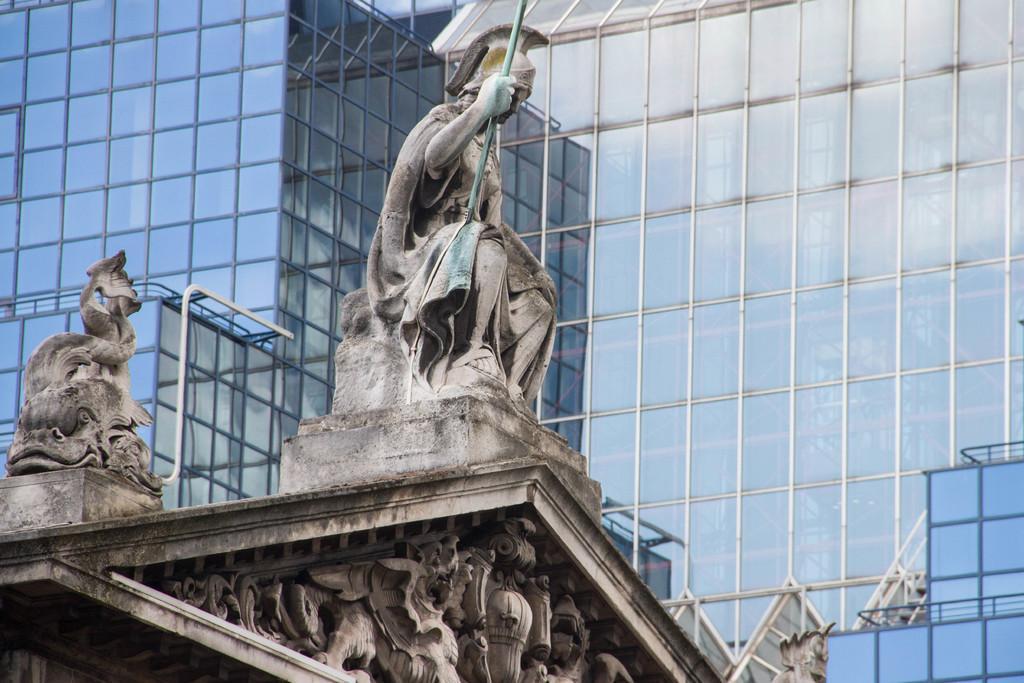Can you describe this image briefly? In the image in the center we can see building,wall and statues. In the background there is a glass building. 